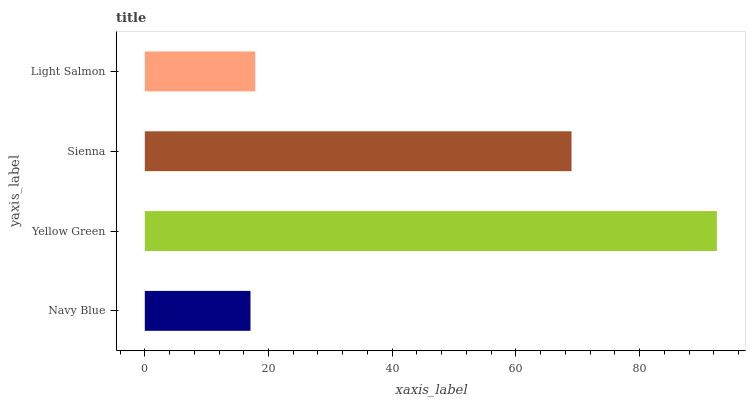Is Navy Blue the minimum?
Answer yes or no. Yes. Is Yellow Green the maximum?
Answer yes or no. Yes. Is Sienna the minimum?
Answer yes or no. No. Is Sienna the maximum?
Answer yes or no. No. Is Yellow Green greater than Sienna?
Answer yes or no. Yes. Is Sienna less than Yellow Green?
Answer yes or no. Yes. Is Sienna greater than Yellow Green?
Answer yes or no. No. Is Yellow Green less than Sienna?
Answer yes or no. No. Is Sienna the high median?
Answer yes or no. Yes. Is Light Salmon the low median?
Answer yes or no. Yes. Is Light Salmon the high median?
Answer yes or no. No. Is Navy Blue the low median?
Answer yes or no. No. 